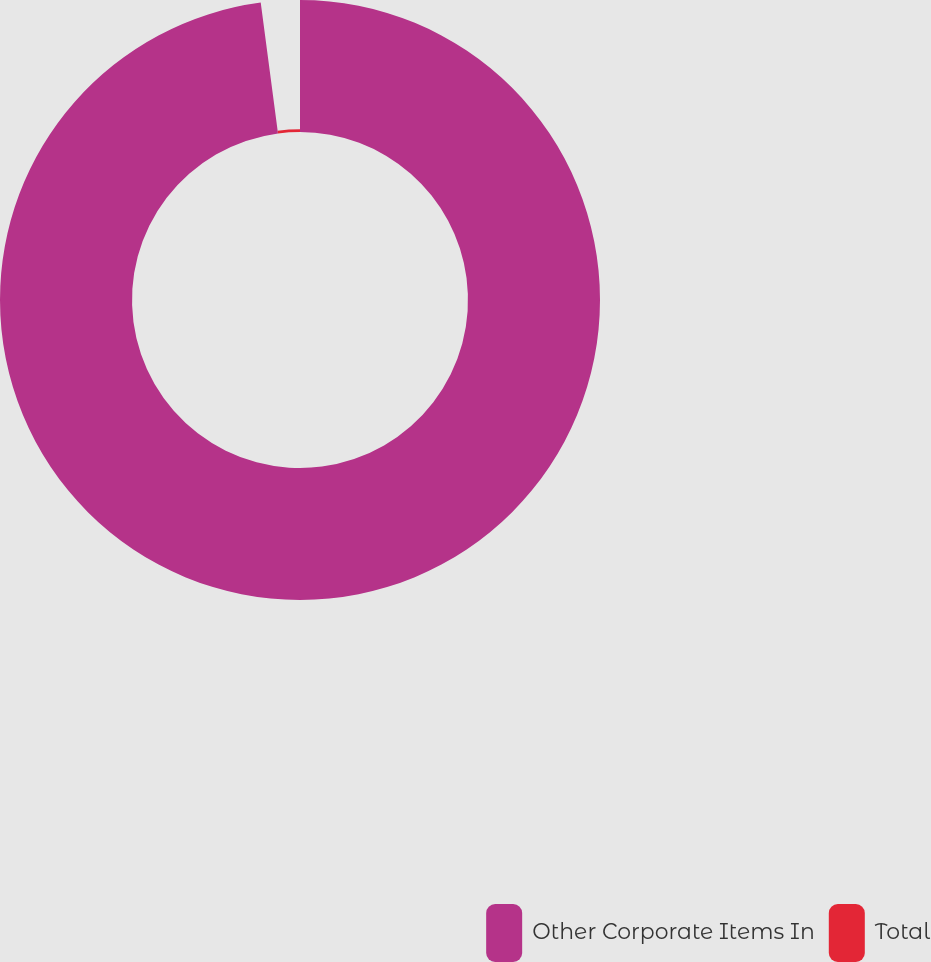Convert chart. <chart><loc_0><loc_0><loc_500><loc_500><pie_chart><fcel>Other Corporate Items In<fcel>Total<nl><fcel>97.91%<fcel>2.09%<nl></chart> 